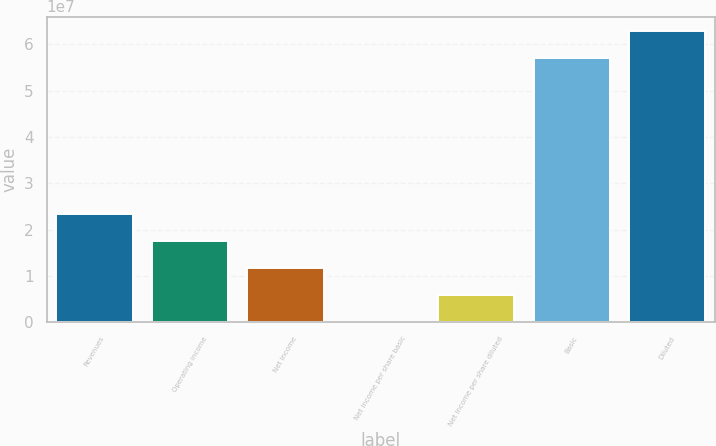<chart> <loc_0><loc_0><loc_500><loc_500><bar_chart><fcel>Revenues<fcel>Operating income<fcel>Net income<fcel>Net income per share basic<fcel>Net income per share diluted<fcel>Basic<fcel>Diluted<nl><fcel>2.33476e+07<fcel>1.75107e+07<fcel>1.16738e+07<fcel>0.1<fcel>5.83691e+06<fcel>5.7038e+07<fcel>6.28749e+07<nl></chart> 